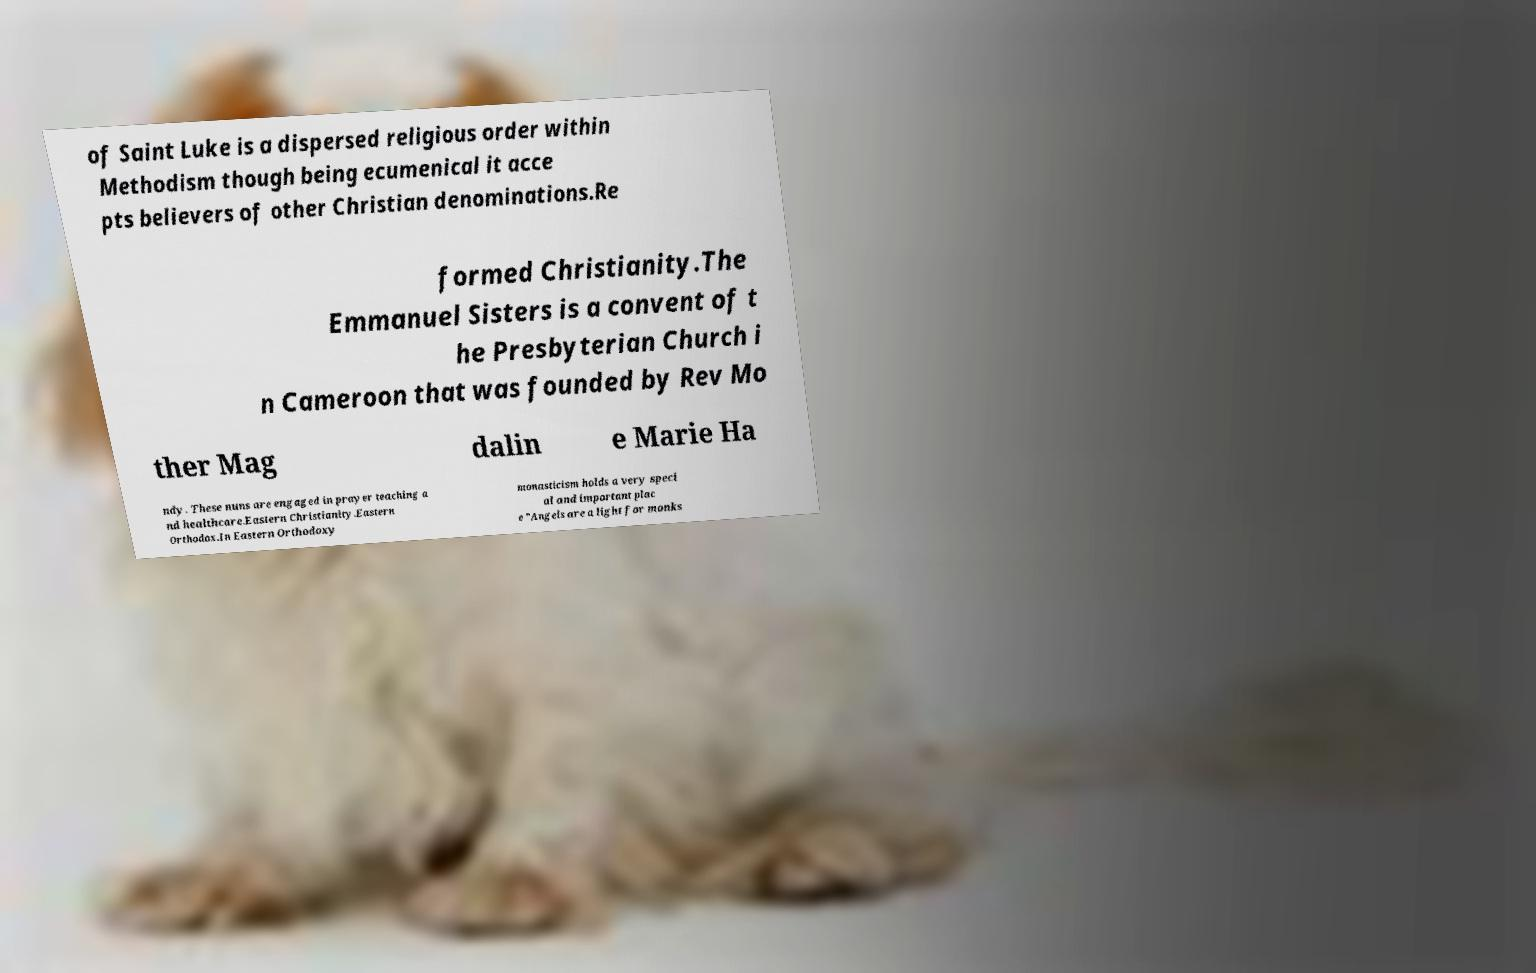Can you accurately transcribe the text from the provided image for me? of Saint Luke is a dispersed religious order within Methodism though being ecumenical it acce pts believers of other Christian denominations.Re formed Christianity.The Emmanuel Sisters is a convent of t he Presbyterian Church i n Cameroon that was founded by Rev Mo ther Mag dalin e Marie Ha ndy. These nuns are engaged in prayer teaching a nd healthcare.Eastern Christianity.Eastern Orthodox.In Eastern Orthodoxy monasticism holds a very speci al and important plac e "Angels are a light for monks 